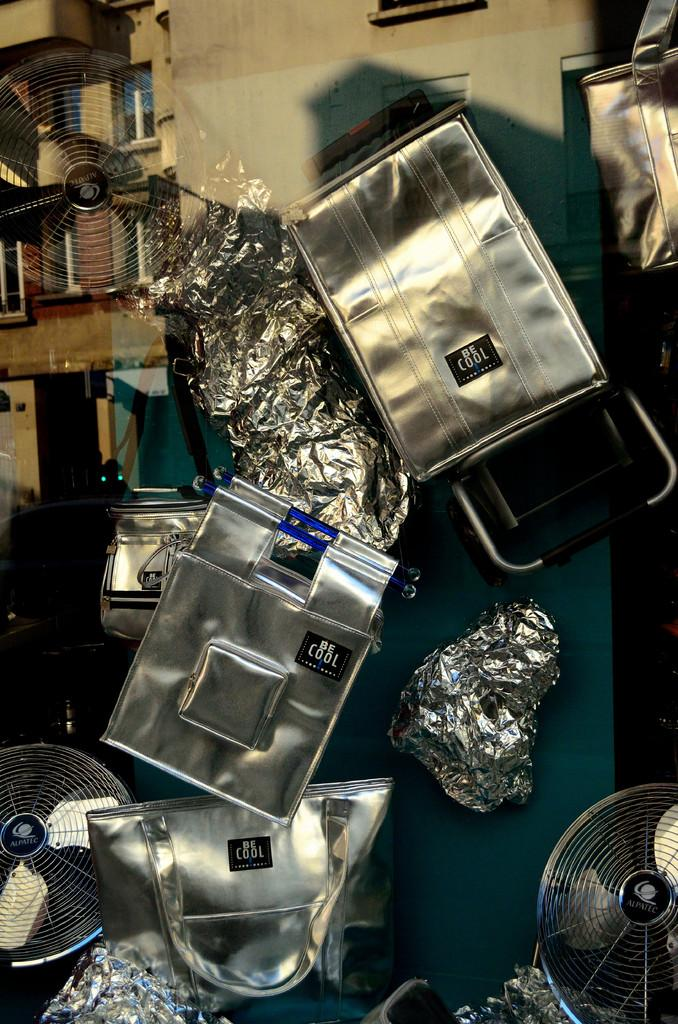What types of items are hanging on the wall in the image? There are different types of bags and fans in the image. Can you describe the bags in the image? The bags in the image are of different types. What else is present on the wall in the image? Fans are also present on the wall in the image. What type of agreement is being signed by the apple in the image? There is no apple present in the image, and therefore no agreement can be signed by an apple. 